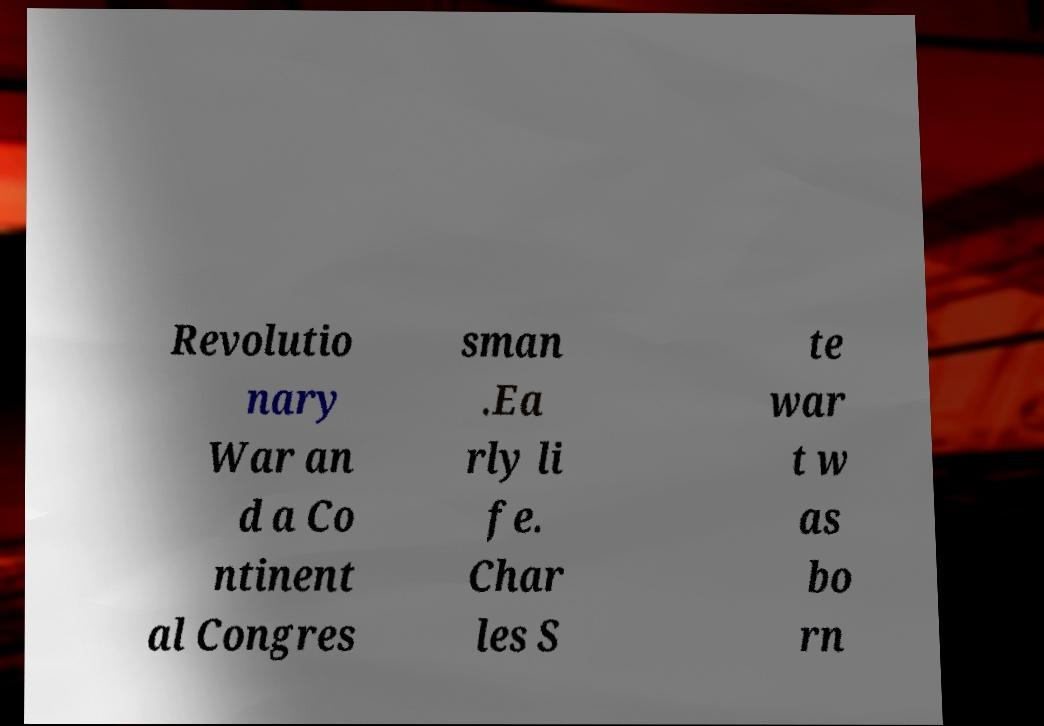Please identify and transcribe the text found in this image. Revolutio nary War an d a Co ntinent al Congres sman .Ea rly li fe. Char les S te war t w as bo rn 